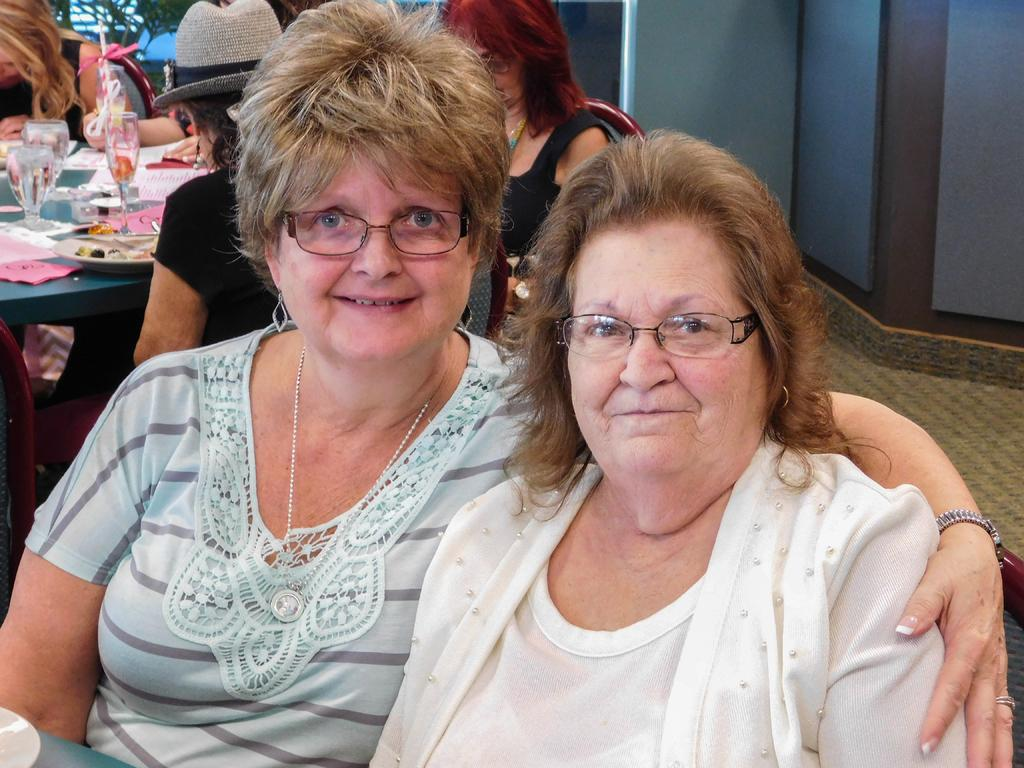How many women are in the image? There are two women in the image. What are the women wearing? The women are wearing spectacles. Can you describe the background of the image? There is a group of people in the background of the image. How much money is being exchanged between the women in the image? There is no indication of money or any exchange taking place in the image. --- Facts: 1. There is a car in the image. 2. The car is parked on the street. 3. There are trees in the background of the image. 4. The sky is visible in the image. Absurd Topics: parrot, ocean, bicycle Conversation: What is the main subject of the image? The main subject of the image is a car. Where is the car located? The car is parked on the street. What can be seen in the background of the image? There are trees in the background of the image. What else is visible in the image? The sky is visible in the image. Reasoning: Let's think step by step in order to produce the conversation. We start by identifying the main subject of the image, which is the car. Then, we describe the location of the car, noting that it is parked on the street. Next, we expand the conversation to include the background of the image, which features trees. Finally, we mention the sky, which is visible in the image. Absurd Question/Answer: Can you see a parrot perched on the car in the image? No, there is no parrot visible in the image. 